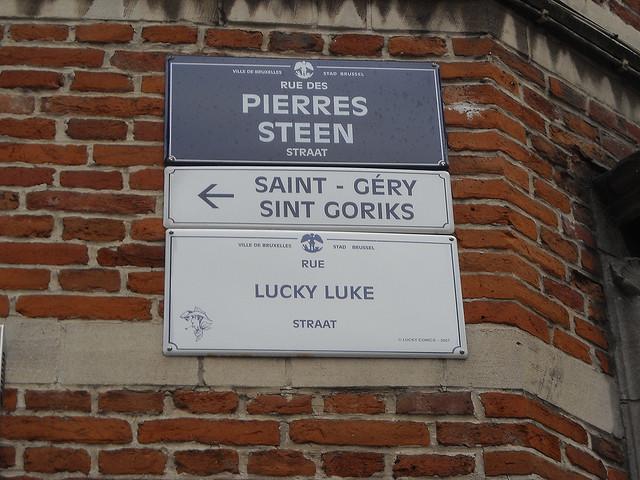Is this an old sign?
Answer briefly. No. What does the sign say?
Concise answer only. Lucky luke. Where was this photo taken?
Short answer required. France. Who is on the front of the building?
Keep it brief. Lucky luke. What is the white sign saying?
Concise answer only. Lucky luke. What does the sign on the side of this building read?
Short answer required. Lucky luke. How many bricks is this wall made out of?
Answer briefly. 100. What color are the bricks?
Keep it brief. Red. What is written beside the arrow?
Quick response, please. Saint gery sint goriks. What language is the signs written in?
Write a very short answer. French. Is the wall made of red brick?
Write a very short answer. Yes. What direction is the arrow pointing?
Give a very brief answer. Left. 